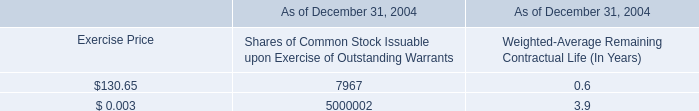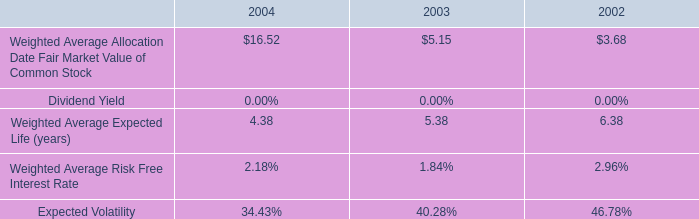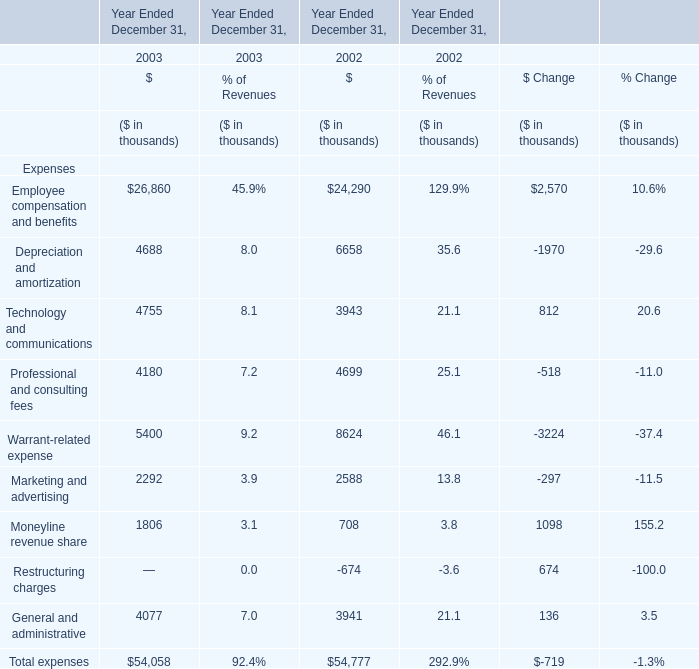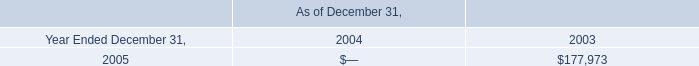What was the total amount of the Warrant-related expense in the years where Depreciation and amortization greater than 0? (in thousand) 
Computations: (5400 + 8624)
Answer: 14024.0. 